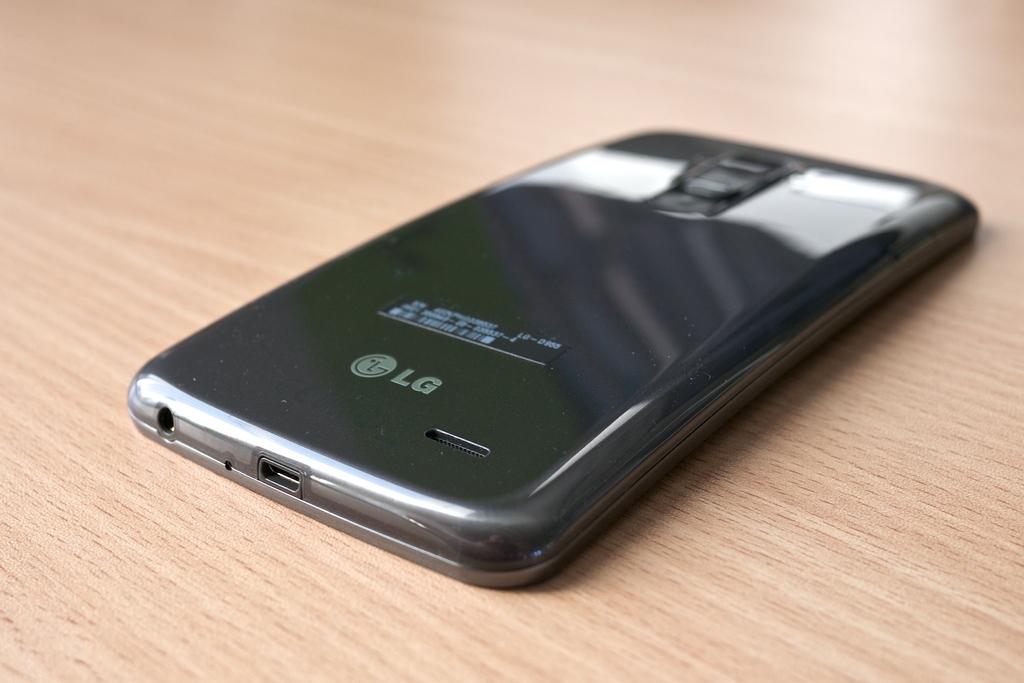What brand of phone is this?
Offer a terse response. Lg. What color is the text of the logo?
Offer a terse response. White. 